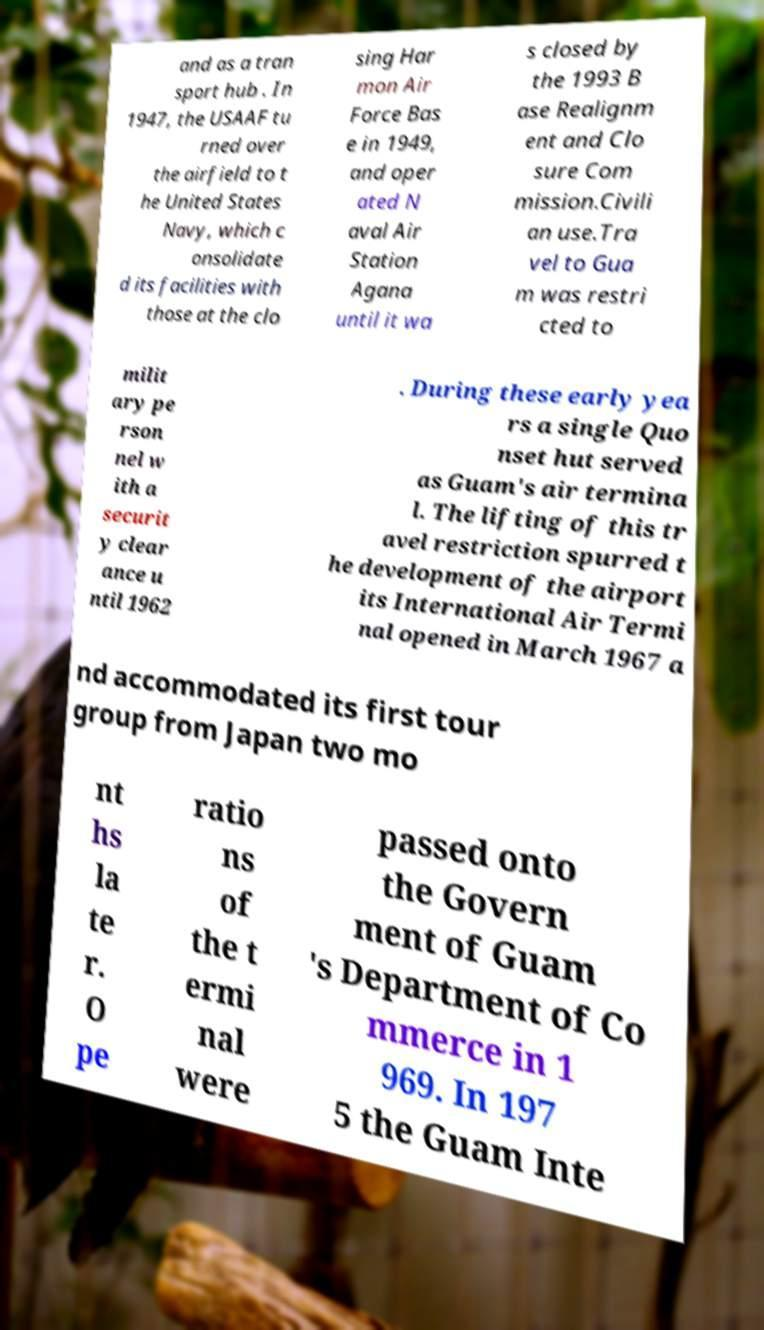Can you accurately transcribe the text from the provided image for me? and as a tran sport hub . In 1947, the USAAF tu rned over the airfield to t he United States Navy, which c onsolidate d its facilities with those at the clo sing Har mon Air Force Bas e in 1949, and oper ated N aval Air Station Agana until it wa s closed by the 1993 B ase Realignm ent and Clo sure Com mission.Civili an use.Tra vel to Gua m was restri cted to milit ary pe rson nel w ith a securit y clear ance u ntil 1962 . During these early yea rs a single Quo nset hut served as Guam's air termina l. The lifting of this tr avel restriction spurred t he development of the airport its International Air Termi nal opened in March 1967 a nd accommodated its first tour group from Japan two mo nt hs la te r. O pe ratio ns of the t ermi nal were passed onto the Govern ment of Guam 's Department of Co mmerce in 1 969. In 197 5 the Guam Inte 